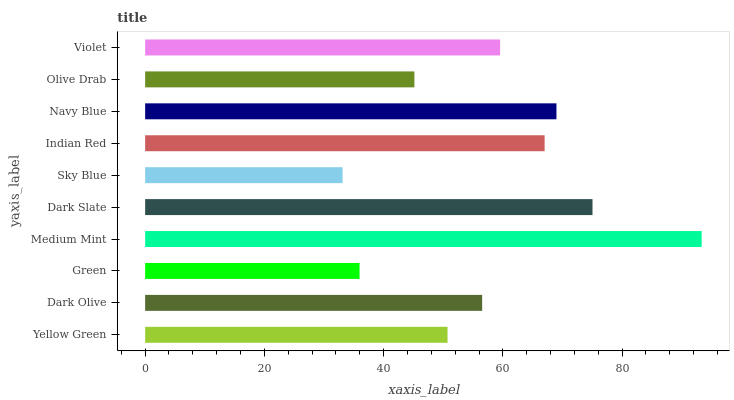Is Sky Blue the minimum?
Answer yes or no. Yes. Is Medium Mint the maximum?
Answer yes or no. Yes. Is Dark Olive the minimum?
Answer yes or no. No. Is Dark Olive the maximum?
Answer yes or no. No. Is Dark Olive greater than Yellow Green?
Answer yes or no. Yes. Is Yellow Green less than Dark Olive?
Answer yes or no. Yes. Is Yellow Green greater than Dark Olive?
Answer yes or no. No. Is Dark Olive less than Yellow Green?
Answer yes or no. No. Is Violet the high median?
Answer yes or no. Yes. Is Dark Olive the low median?
Answer yes or no. Yes. Is Dark Slate the high median?
Answer yes or no. No. Is Navy Blue the low median?
Answer yes or no. No. 